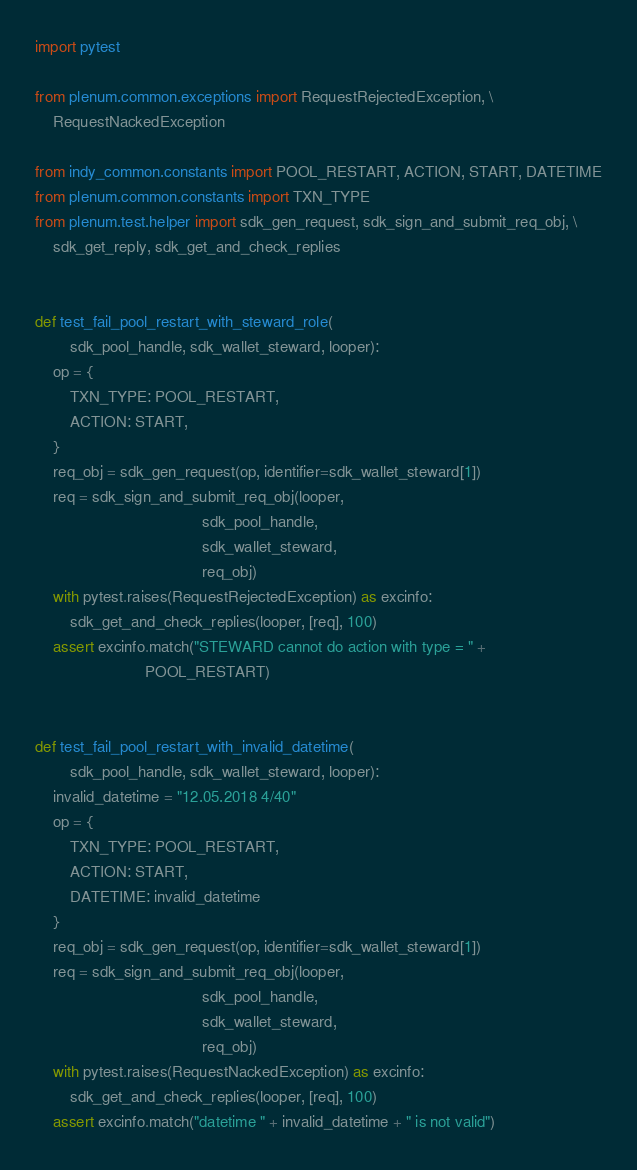<code> <loc_0><loc_0><loc_500><loc_500><_Python_>import pytest

from plenum.common.exceptions import RequestRejectedException, \
    RequestNackedException

from indy_common.constants import POOL_RESTART, ACTION, START, DATETIME
from plenum.common.constants import TXN_TYPE
from plenum.test.helper import sdk_gen_request, sdk_sign_and_submit_req_obj, \
    sdk_get_reply, sdk_get_and_check_replies


def test_fail_pool_restart_with_steward_role(
        sdk_pool_handle, sdk_wallet_steward, looper):
    op = {
        TXN_TYPE: POOL_RESTART,
        ACTION: START,
    }
    req_obj = sdk_gen_request(op, identifier=sdk_wallet_steward[1])
    req = sdk_sign_and_submit_req_obj(looper,
                                      sdk_pool_handle,
                                      sdk_wallet_steward,
                                      req_obj)
    with pytest.raises(RequestRejectedException) as excinfo:
        sdk_get_and_check_replies(looper, [req], 100)
    assert excinfo.match("STEWARD cannot do action with type = " +
                         POOL_RESTART)


def test_fail_pool_restart_with_invalid_datetime(
        sdk_pool_handle, sdk_wallet_steward, looper):
    invalid_datetime = "12.05.2018 4/40"
    op = {
        TXN_TYPE: POOL_RESTART,
        ACTION: START,
        DATETIME: invalid_datetime
    }
    req_obj = sdk_gen_request(op, identifier=sdk_wallet_steward[1])
    req = sdk_sign_and_submit_req_obj(looper,
                                      sdk_pool_handle,
                                      sdk_wallet_steward,
                                      req_obj)
    with pytest.raises(RequestNackedException) as excinfo:
        sdk_get_and_check_replies(looper, [req], 100)
    assert excinfo.match("datetime " + invalid_datetime + " is not valid")

</code> 